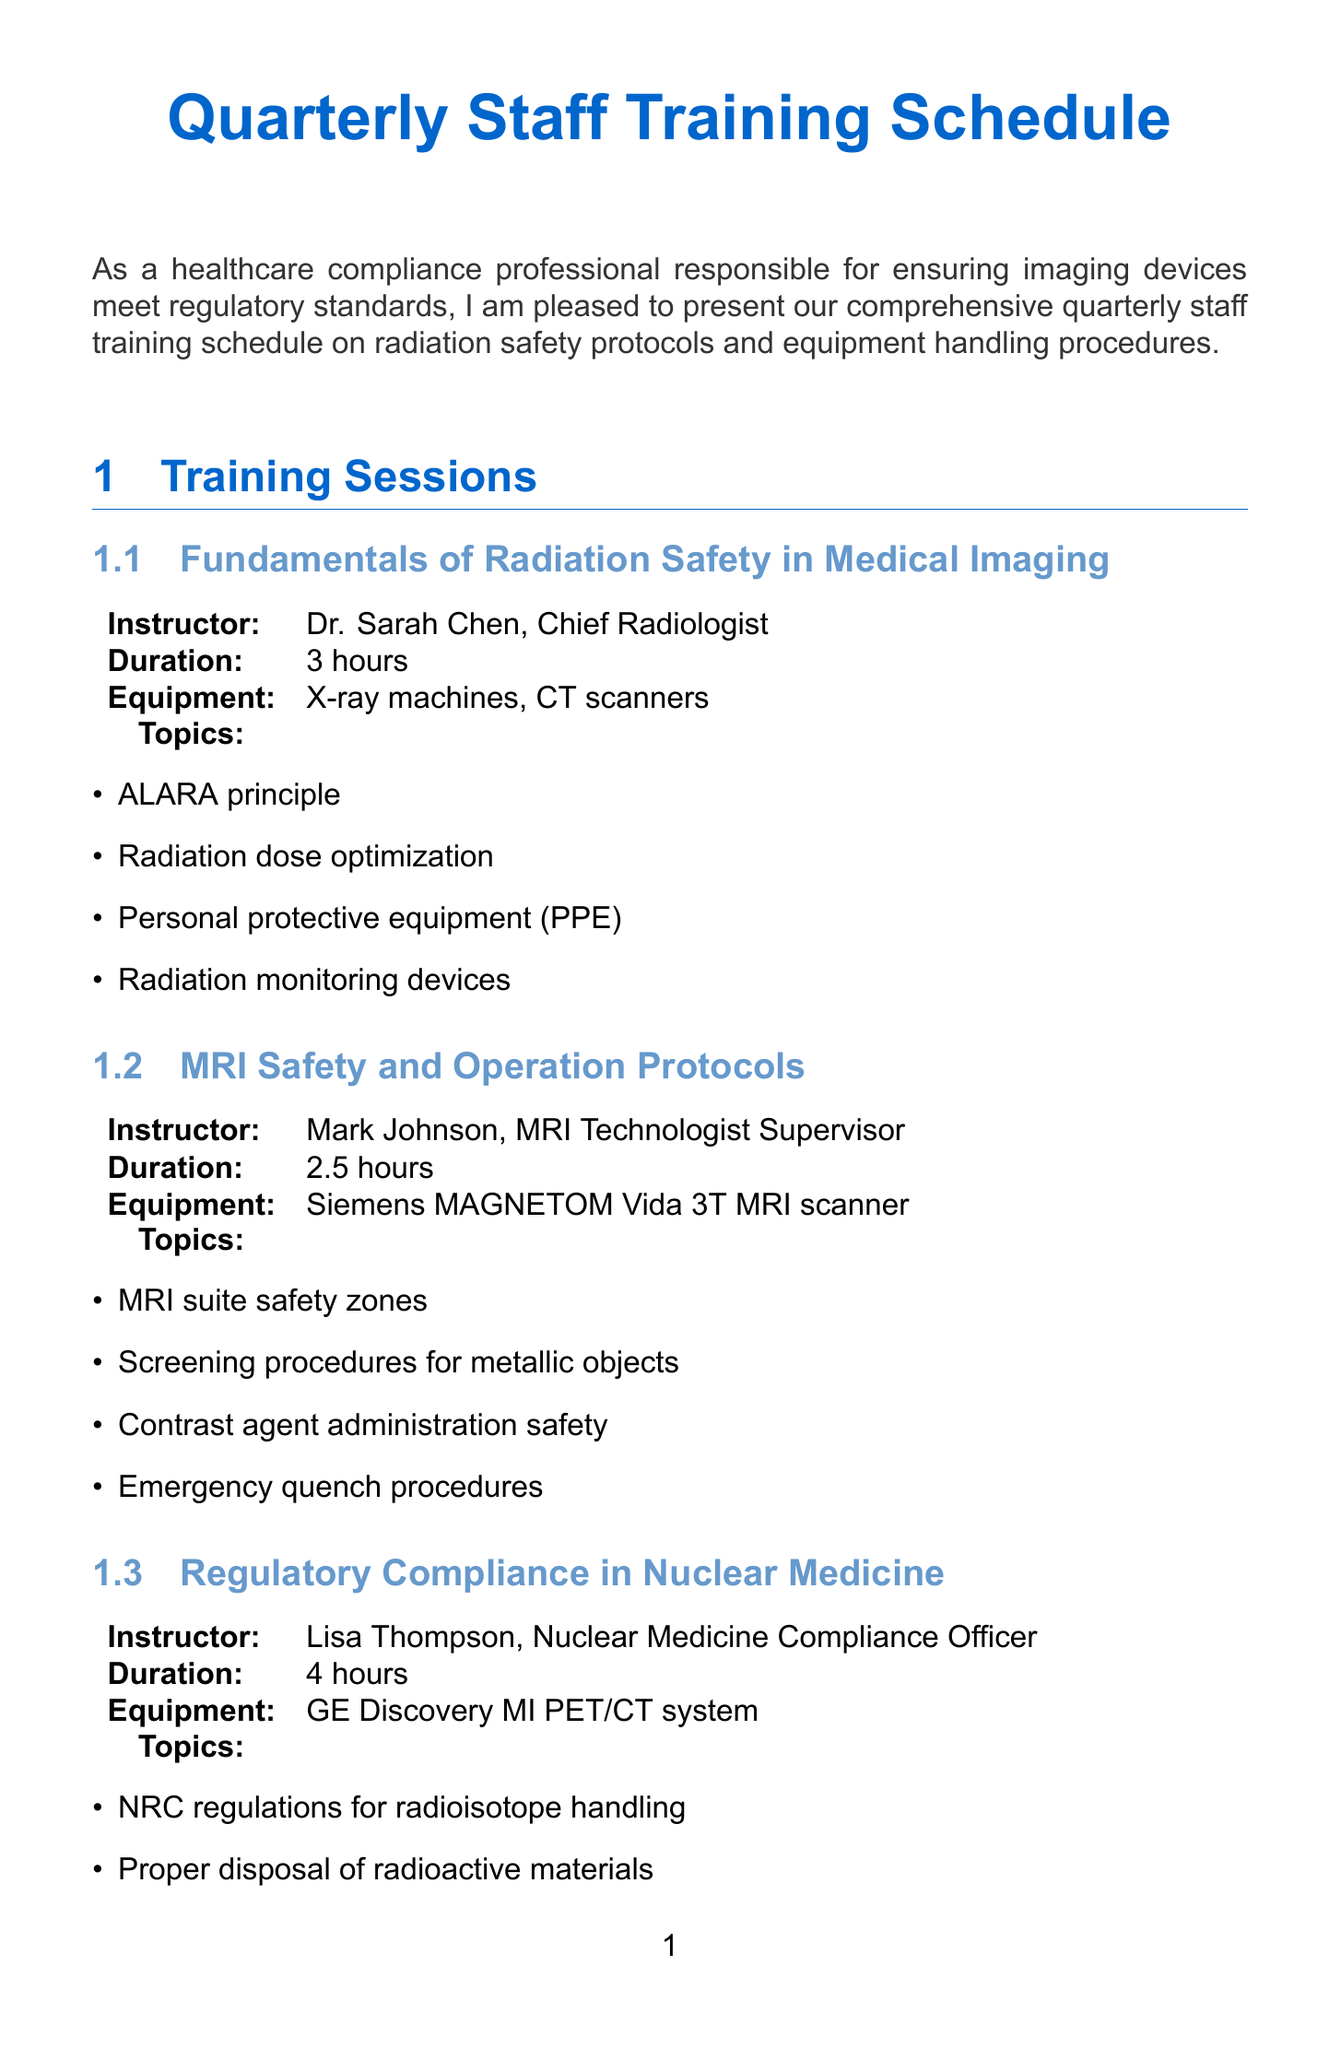What is the title of the first training session? The title of the first training session can be found under the section titles, which includes all the training topics.
Answer: Fundamentals of Radiation Safety in Medical Imaging Who is the instructor for the "Updates on FDA and Joint Commission Regulations" session? Each training session lists the instructor at the beginning of the detailed section.
Answer: Michael Brown, Healthcare Compliance Consultant What is the duration of the "Quality Control and Calibration of Imaging Equipment" session? The duration is specified for each training session in the document, particularly under the session details.
Answer: 3.5 hours Which equipment is focused on in the "MRI Safety and Operation Protocols" training? Equipment focus is listed directly in the training session details under each session.
Answer: Siemens MAGNETOM Vida 3T MRI scanner How many topics are covered in the "Emergency Response and Equipment Malfunction Protocols" session? The number of topics covered can be counted from the list provided under the session details.
Answer: 4 What is the main focus of the training sessions listed in the document? The document defines the purpose of the training sessions by mentioning "radiation safety protocols and equipment handling procedures."
Answer: Radiation safety protocols and equipment handling procedures Which compliance officer is responsible for the "Regulatory Compliance in Nuclear Medicine" session? Each instructor's role is mentioned with their name next to the session title.
Answer: Lisa Thompson, Nuclear Medicine Compliance Officer 